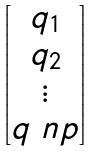<formula> <loc_0><loc_0><loc_500><loc_500>\begin{bmatrix} q _ { 1 } \\ q _ { 2 } \\ \vdots \\ q _ { \ } n p \end{bmatrix}</formula> 